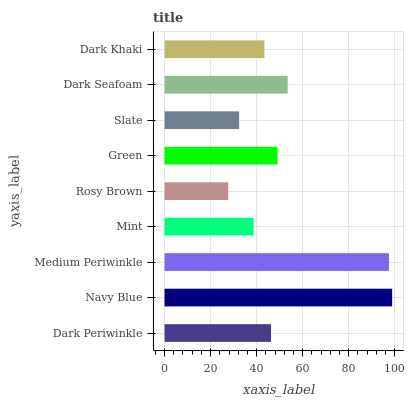Is Rosy Brown the minimum?
Answer yes or no. Yes. Is Navy Blue the maximum?
Answer yes or no. Yes. Is Medium Periwinkle the minimum?
Answer yes or no. No. Is Medium Periwinkle the maximum?
Answer yes or no. No. Is Navy Blue greater than Medium Periwinkle?
Answer yes or no. Yes. Is Medium Periwinkle less than Navy Blue?
Answer yes or no. Yes. Is Medium Periwinkle greater than Navy Blue?
Answer yes or no. No. Is Navy Blue less than Medium Periwinkle?
Answer yes or no. No. Is Dark Periwinkle the high median?
Answer yes or no. Yes. Is Dark Periwinkle the low median?
Answer yes or no. Yes. Is Navy Blue the high median?
Answer yes or no. No. Is Rosy Brown the low median?
Answer yes or no. No. 